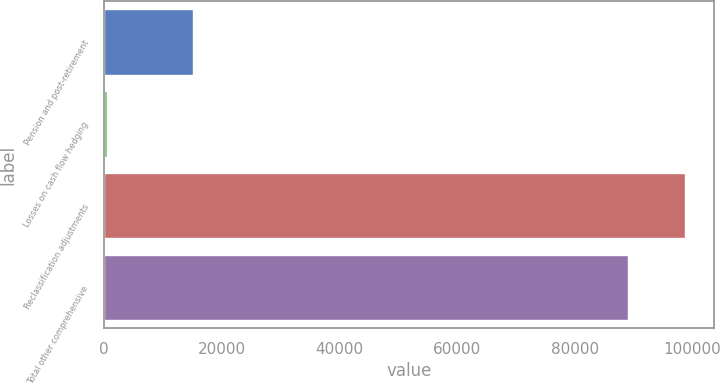Convert chart to OTSL. <chart><loc_0><loc_0><loc_500><loc_500><bar_chart><fcel>Pension and post-retirement<fcel>Losses on cash flow hedging<fcel>Reclassification adjustments<fcel>Total other comprehensive<nl><fcel>15159<fcel>543<fcel>98650<fcel>89005<nl></chart> 